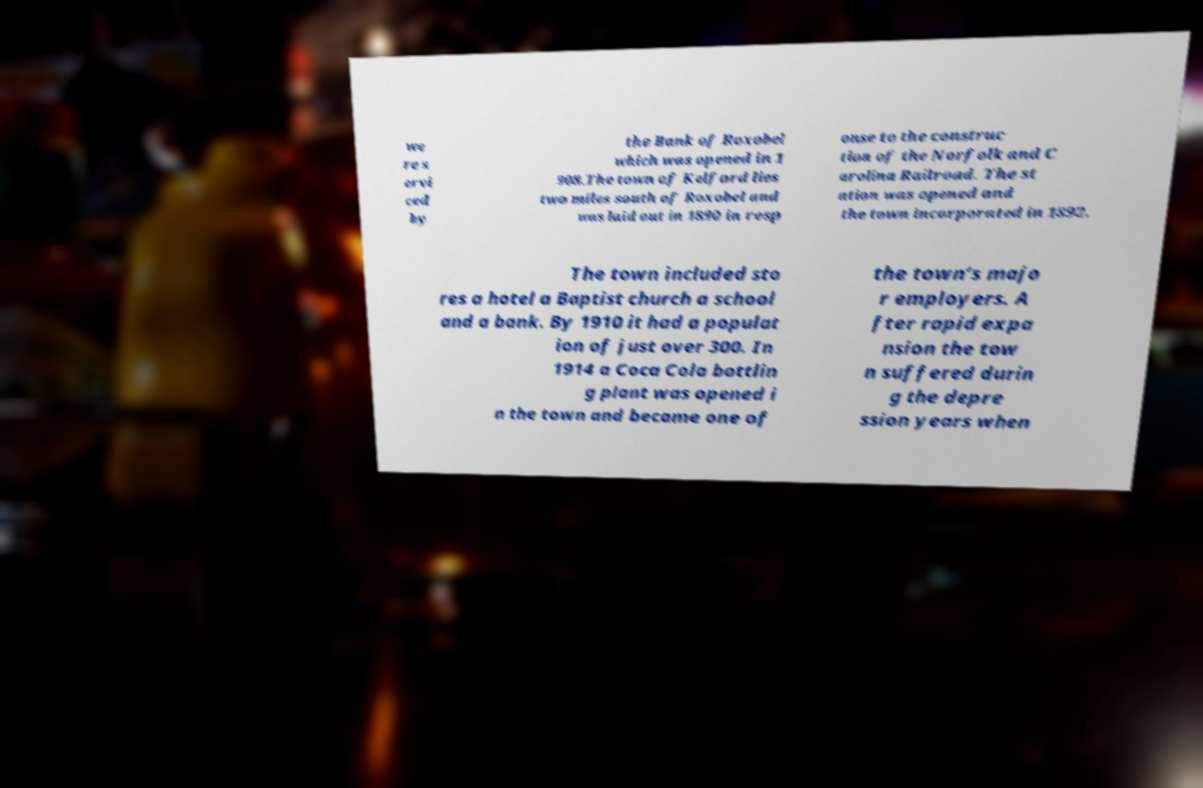Please identify and transcribe the text found in this image. we re s ervi ced by the Bank of Roxobel which was opened in 1 908.The town of Kelford lies two miles south of Roxobel and was laid out in 1890 in resp onse to the construc tion of the Norfolk and C arolina Railroad. The st ation was opened and the town incorporated in 1892. The town included sto res a hotel a Baptist church a school and a bank. By 1910 it had a populat ion of just over 300. In 1914 a Coca Cola bottlin g plant was opened i n the town and became one of the town’s majo r employers. A fter rapid expa nsion the tow n suffered durin g the depre ssion years when 